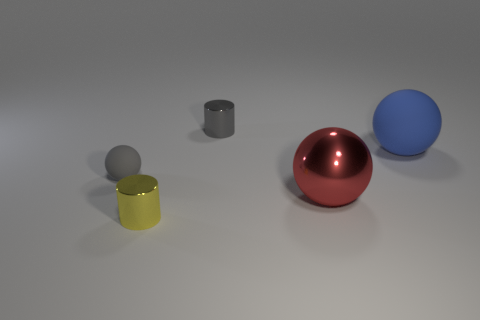Subtract all large spheres. How many spheres are left? 1 Add 1 large yellow cubes. How many objects exist? 6 Subtract all gray cylinders. How many cylinders are left? 1 Subtract 0 yellow balls. How many objects are left? 5 Subtract all balls. How many objects are left? 2 Subtract 3 spheres. How many spheres are left? 0 Subtract all gray spheres. Subtract all purple cubes. How many spheres are left? 2 Subtract all red shiny balls. Subtract all tiny gray metallic cylinders. How many objects are left? 3 Add 5 yellow metallic cylinders. How many yellow metallic cylinders are left? 6 Add 5 gray matte things. How many gray matte things exist? 6 